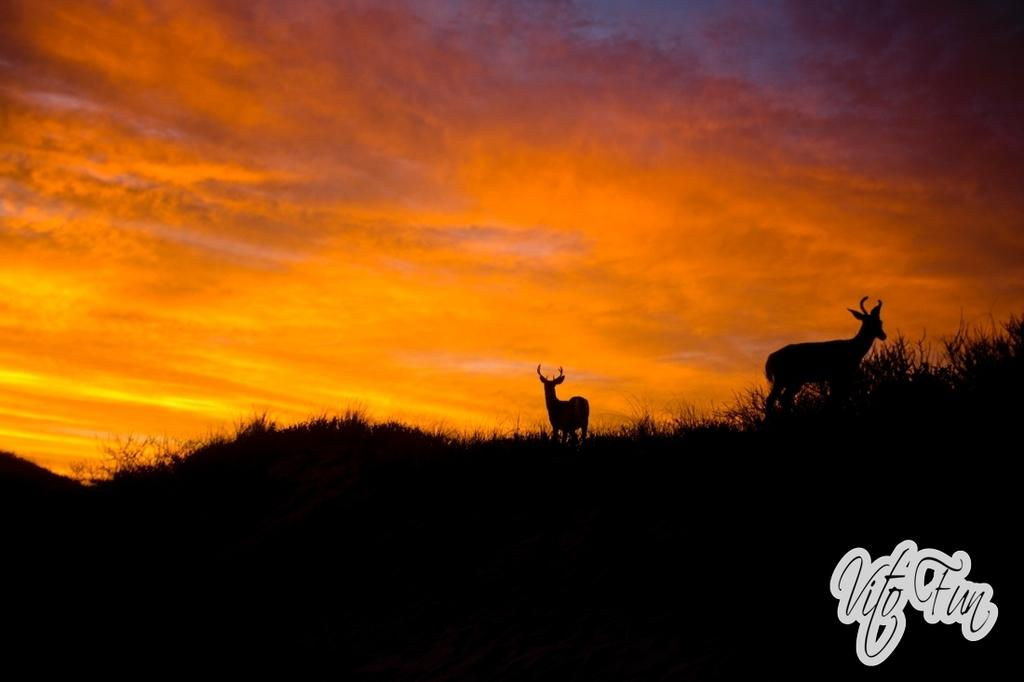How many animals are present in the image? There are two animals in the image. Can you describe the sky in the background? The sky in the background has orange, blue, and gray colors. What type of mice can be seen operating the apparatus in the image? There are no mice or apparatus present in the image. Where is the store located in the image? There is no store present in the image. 